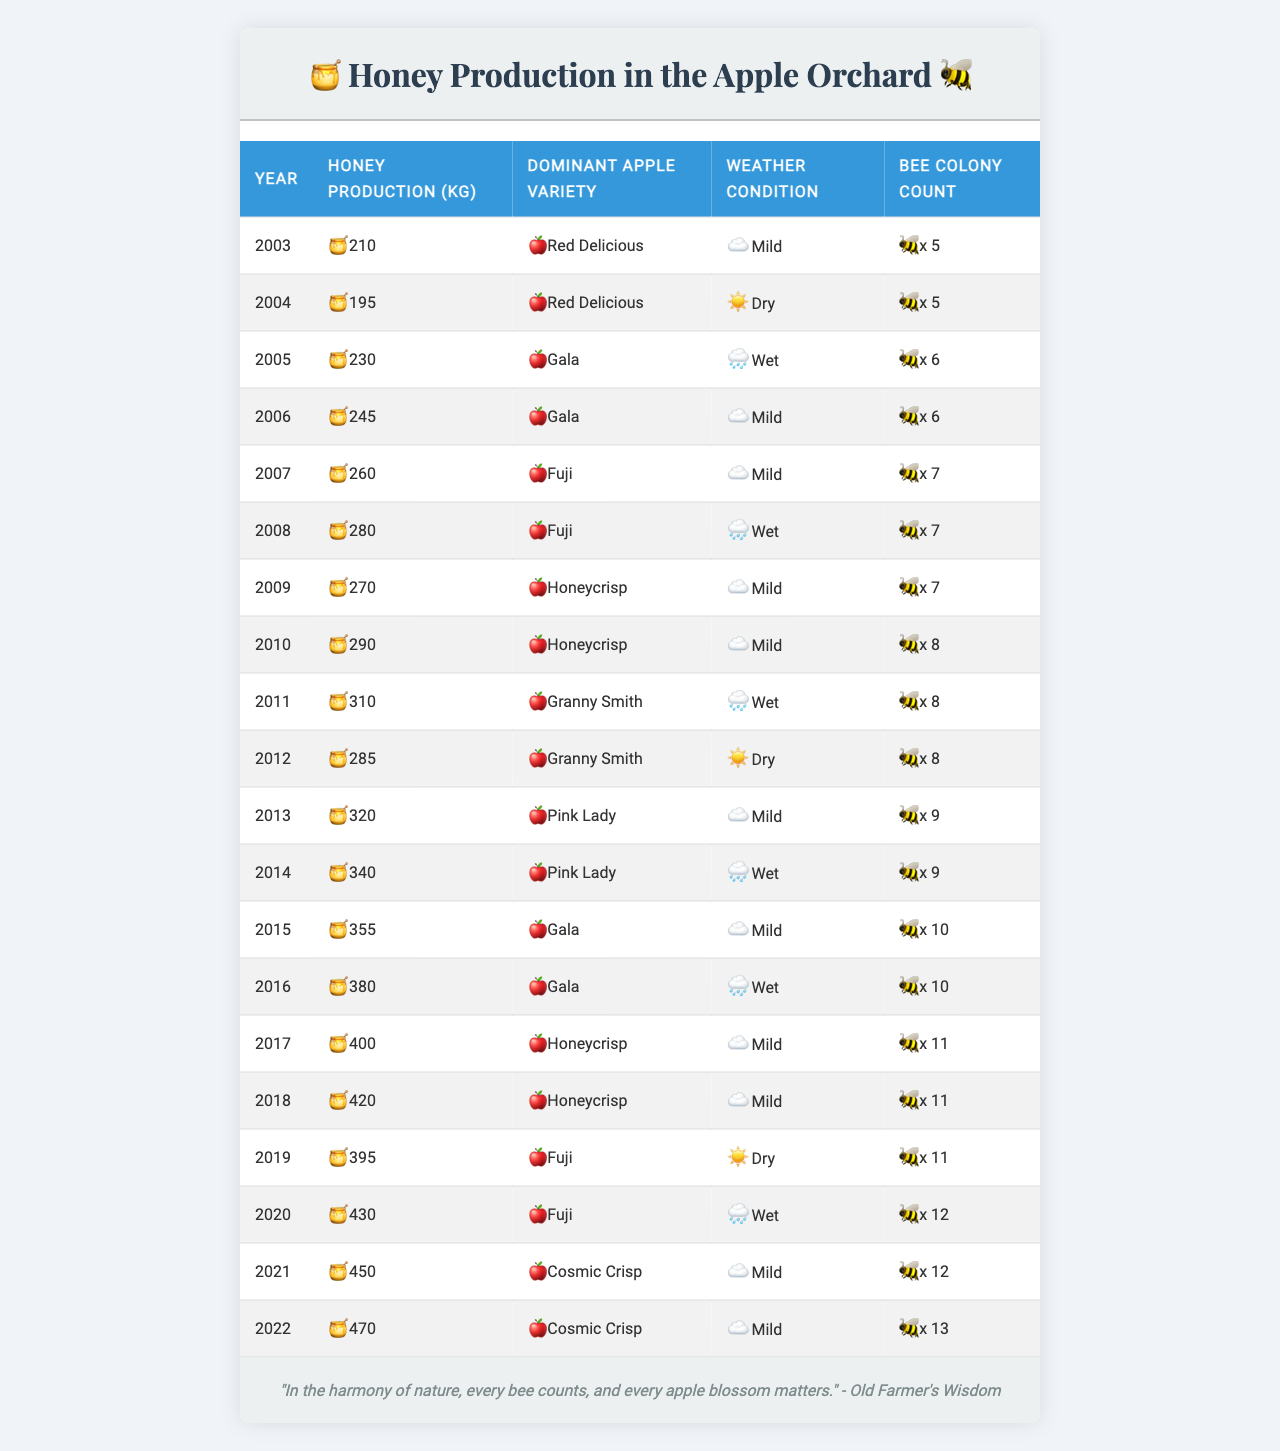What was the highest honey production recorded in the orchard? The highest honey production in the table is 470 kg, which was recorded in the year 2022.
Answer: 470 kg In which year did the apple harvest yield the least honey? The least honey production was in the year 2004 when only 195 kg was produced.
Answer: 2004 How many bee colonies were there in 2015? According to the table, there were 10 bee colonies in the year 2015.
Answer: 10 What is the average honey production from 2010 to 2020? The honey productions during those years are 290, 310, 320, 340, 355, 380, 400, 420, and 430 kg. Summing these gives 290 + 310 + 320 + 340 + 355 + 380 + 400 + 420 + 430 =  3255 kg. Dividing by 9 (the number of years) gives an average of 361.67 kg. Therefore, the average rounded to the nearest whole number is 362 kg.
Answer: 362 kg Was the dominant apple variety the same in 2003 and 2004? In 2003, the dominant apple variety was Red Delicious, while in 2004, it remained Red Delicious. So, yes, they were the same.
Answer: Yes During which year did the honey production exceed 400 kg for the first time? The first year that honey production exceeded 400 kg was in 2017 when it reached 400 kg.
Answer: 2017 What was the total honey production across the years 2011 to 2021? The honey productions from 2011 to 2021 are 310, 285, 320, 340, 355, 380, 400, 420, and 430 kg. Summing these values gives 310 + 285 + 320 + 340 + 355 + 380 + 400 + 420 + 430 =  2820 kg.
Answer: 2820 kg Did the honey production increase or decrease from 2018 to 2019? In 2018, honey production was 420 kg, and in 2019, it decreased to 395 kg. Therefore, there was a decrease.
Answer: Decrease How many more bee colonies were there in 2022 compared to 2003? There were 13 bee colonies in 2022 and 5 in 2003. The difference is 13 - 5 = 8.
Answer: 8 What was the weather condition in 2011, and how did it compare to the following year? In 2011, the weather condition was Wet, while in 2012, it was Dry. Hence, it changed from Wet to Dry.
Answer: Changed from Wet to Dry Which year saw the highest increase in honey production compared to the previous year? To find the highest increase, we will compare the productions year by year. Analyzing the differences, the highest increase is from 2014 to 2015 (340 kg in 2014 to 355 kg in 2015), showing an increase of 15 kg.
Answer: 15 kg increase from 2014 to 2015 